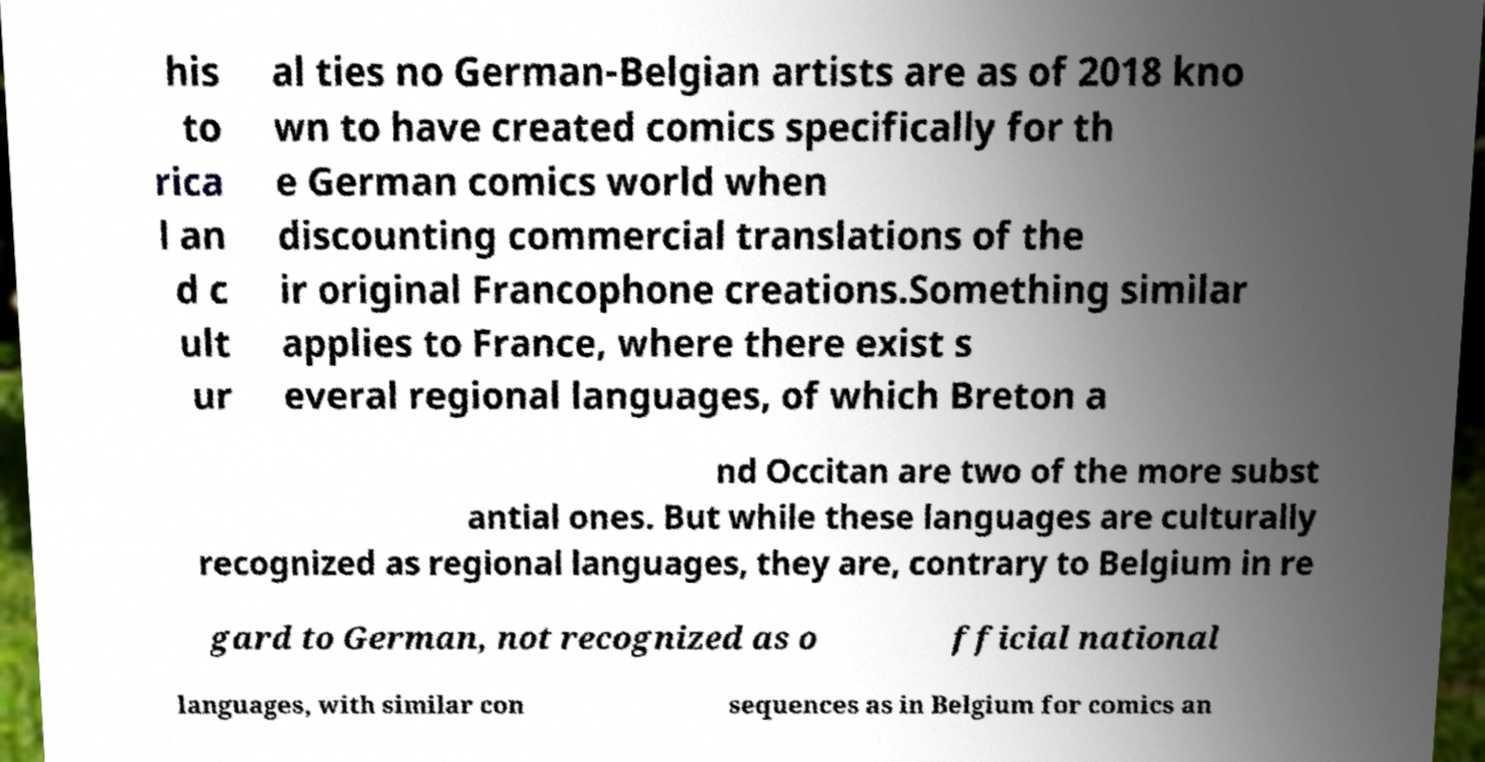There's text embedded in this image that I need extracted. Can you transcribe it verbatim? his to rica l an d c ult ur al ties no German-Belgian artists are as of 2018 kno wn to have created comics specifically for th e German comics world when discounting commercial translations of the ir original Francophone creations.Something similar applies to France, where there exist s everal regional languages, of which Breton a nd Occitan are two of the more subst antial ones. But while these languages are culturally recognized as regional languages, they are, contrary to Belgium in re gard to German, not recognized as o fficial national languages, with similar con sequences as in Belgium for comics an 